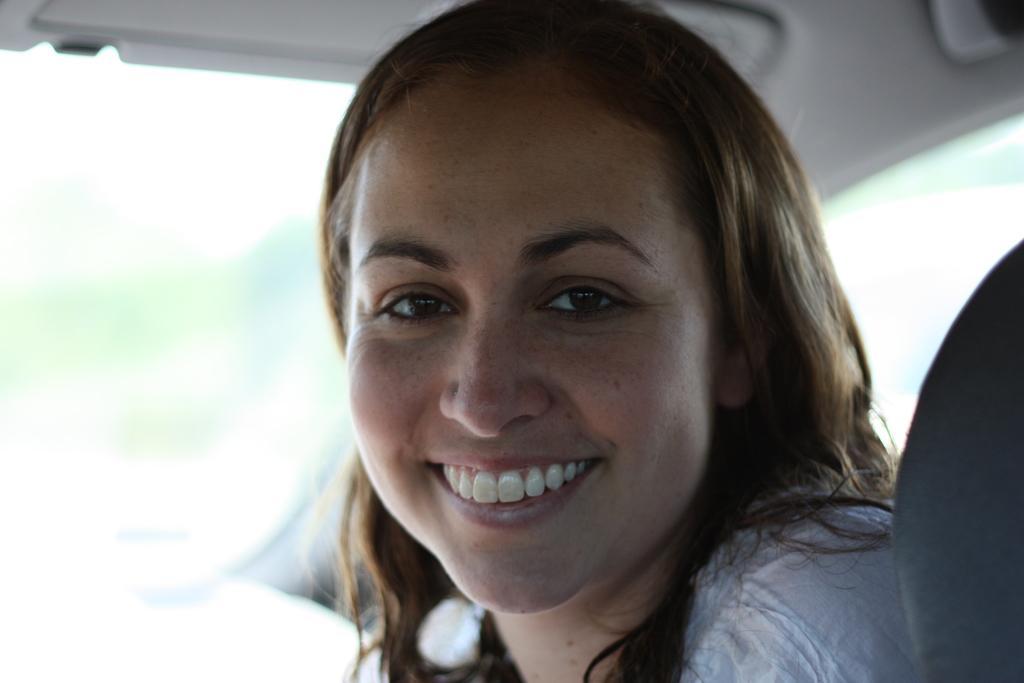Please provide a concise description of this image. In the foreground of this image, it seems like there is a woman sitting on the seat inside a vehicle. 